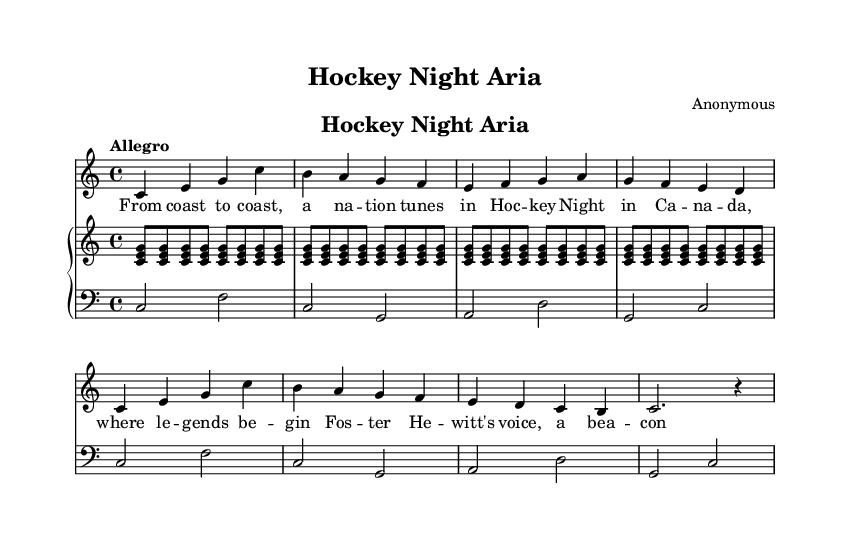What is the key signature of this music? The key signature is indicated by the absence of sharps or flats, indicating it is in C major.
Answer: C major What is the time signature of the piece? The time signature is indicated at the beginning of the score as "4/4", which means there are four beats in a measure and each quarter note gets one beat.
Answer: 4/4 What is the tempo marking for this opera piece? The tempo marking is found at the beginning of the score and indicates "Allegro", which generally means to perform the piece at a quick and lively tempo.
Answer: Allegro How many measures are in the soprano part? To find the number of measures, we can count the number of vertical lines which represent bar lines. There are 8 measures in the soprano part.
Answer: 8 How many beats does the last note in the soprano part receive? The last note is a dotted half note, which in 4/4 time, receives three beats prior to a rest that receives the remaining beat in that measure.
Answer: 3 What themes does the soprano lyrics suggest regarding Hockey Night in Canada? The lyrics reflect a sense of national unity and celebration, capturing the excitement and cultural significance of Hockey Night in Canada as a cherished collective experience.
Answer: Unity and celebration 